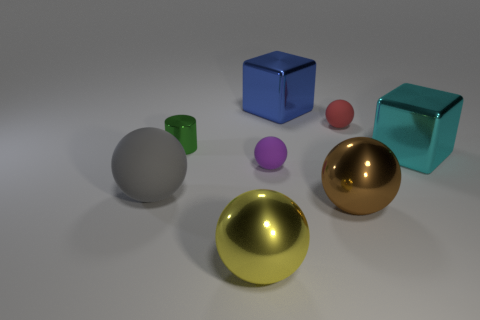Subtract all small purple rubber spheres. How many spheres are left? 4 Subtract all gray balls. How many balls are left? 4 Add 1 big cyan metal blocks. How many objects exist? 9 Subtract all green balls. Subtract all yellow blocks. How many balls are left? 5 Add 4 large gray spheres. How many large gray spheres are left? 5 Add 4 small red things. How many small red things exist? 5 Subtract 0 yellow blocks. How many objects are left? 8 Subtract all cylinders. How many objects are left? 7 Subtract all cubes. Subtract all green metallic cylinders. How many objects are left? 5 